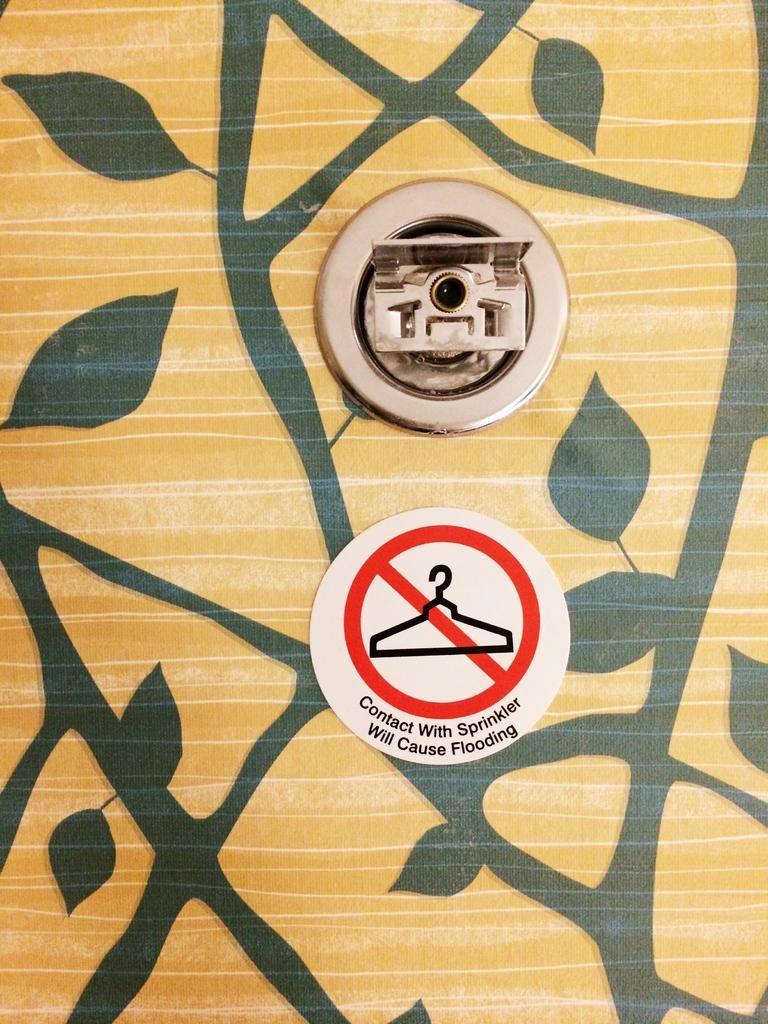Describe this image in one or two sentences. In this picture I can see painting on the wall and a caution sticker with some text on it and I can see a sprinkler. 